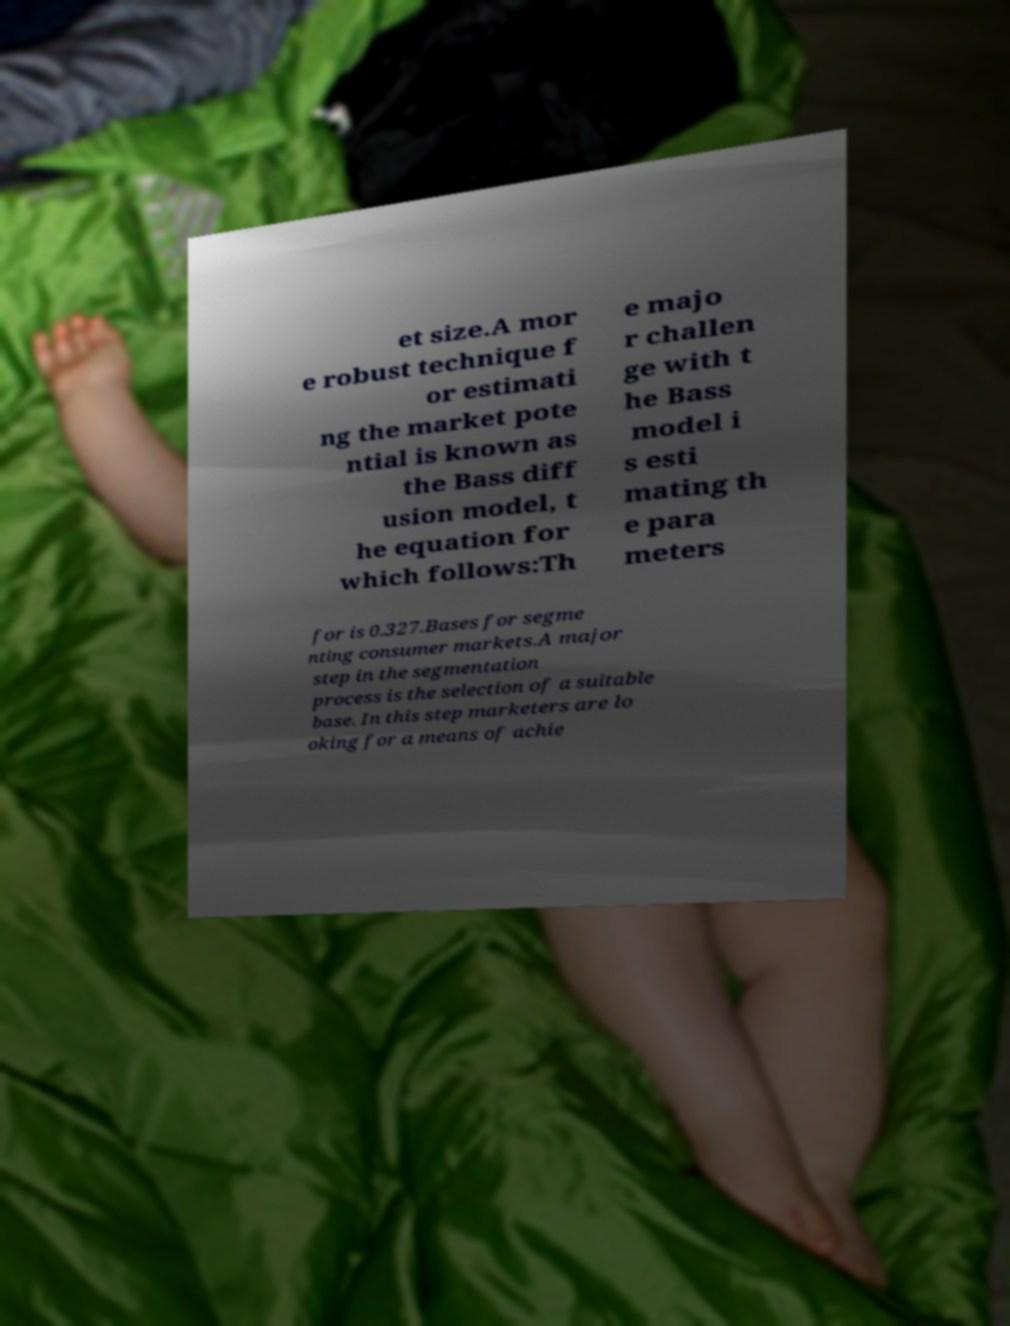What messages or text are displayed in this image? I need them in a readable, typed format. et size.A mor e robust technique f or estimati ng the market pote ntial is known as the Bass diff usion model, t he equation for which follows:Th e majo r challen ge with t he Bass model i s esti mating th e para meters for is 0.327.Bases for segme nting consumer markets.A major step in the segmentation process is the selection of a suitable base. In this step marketers are lo oking for a means of achie 